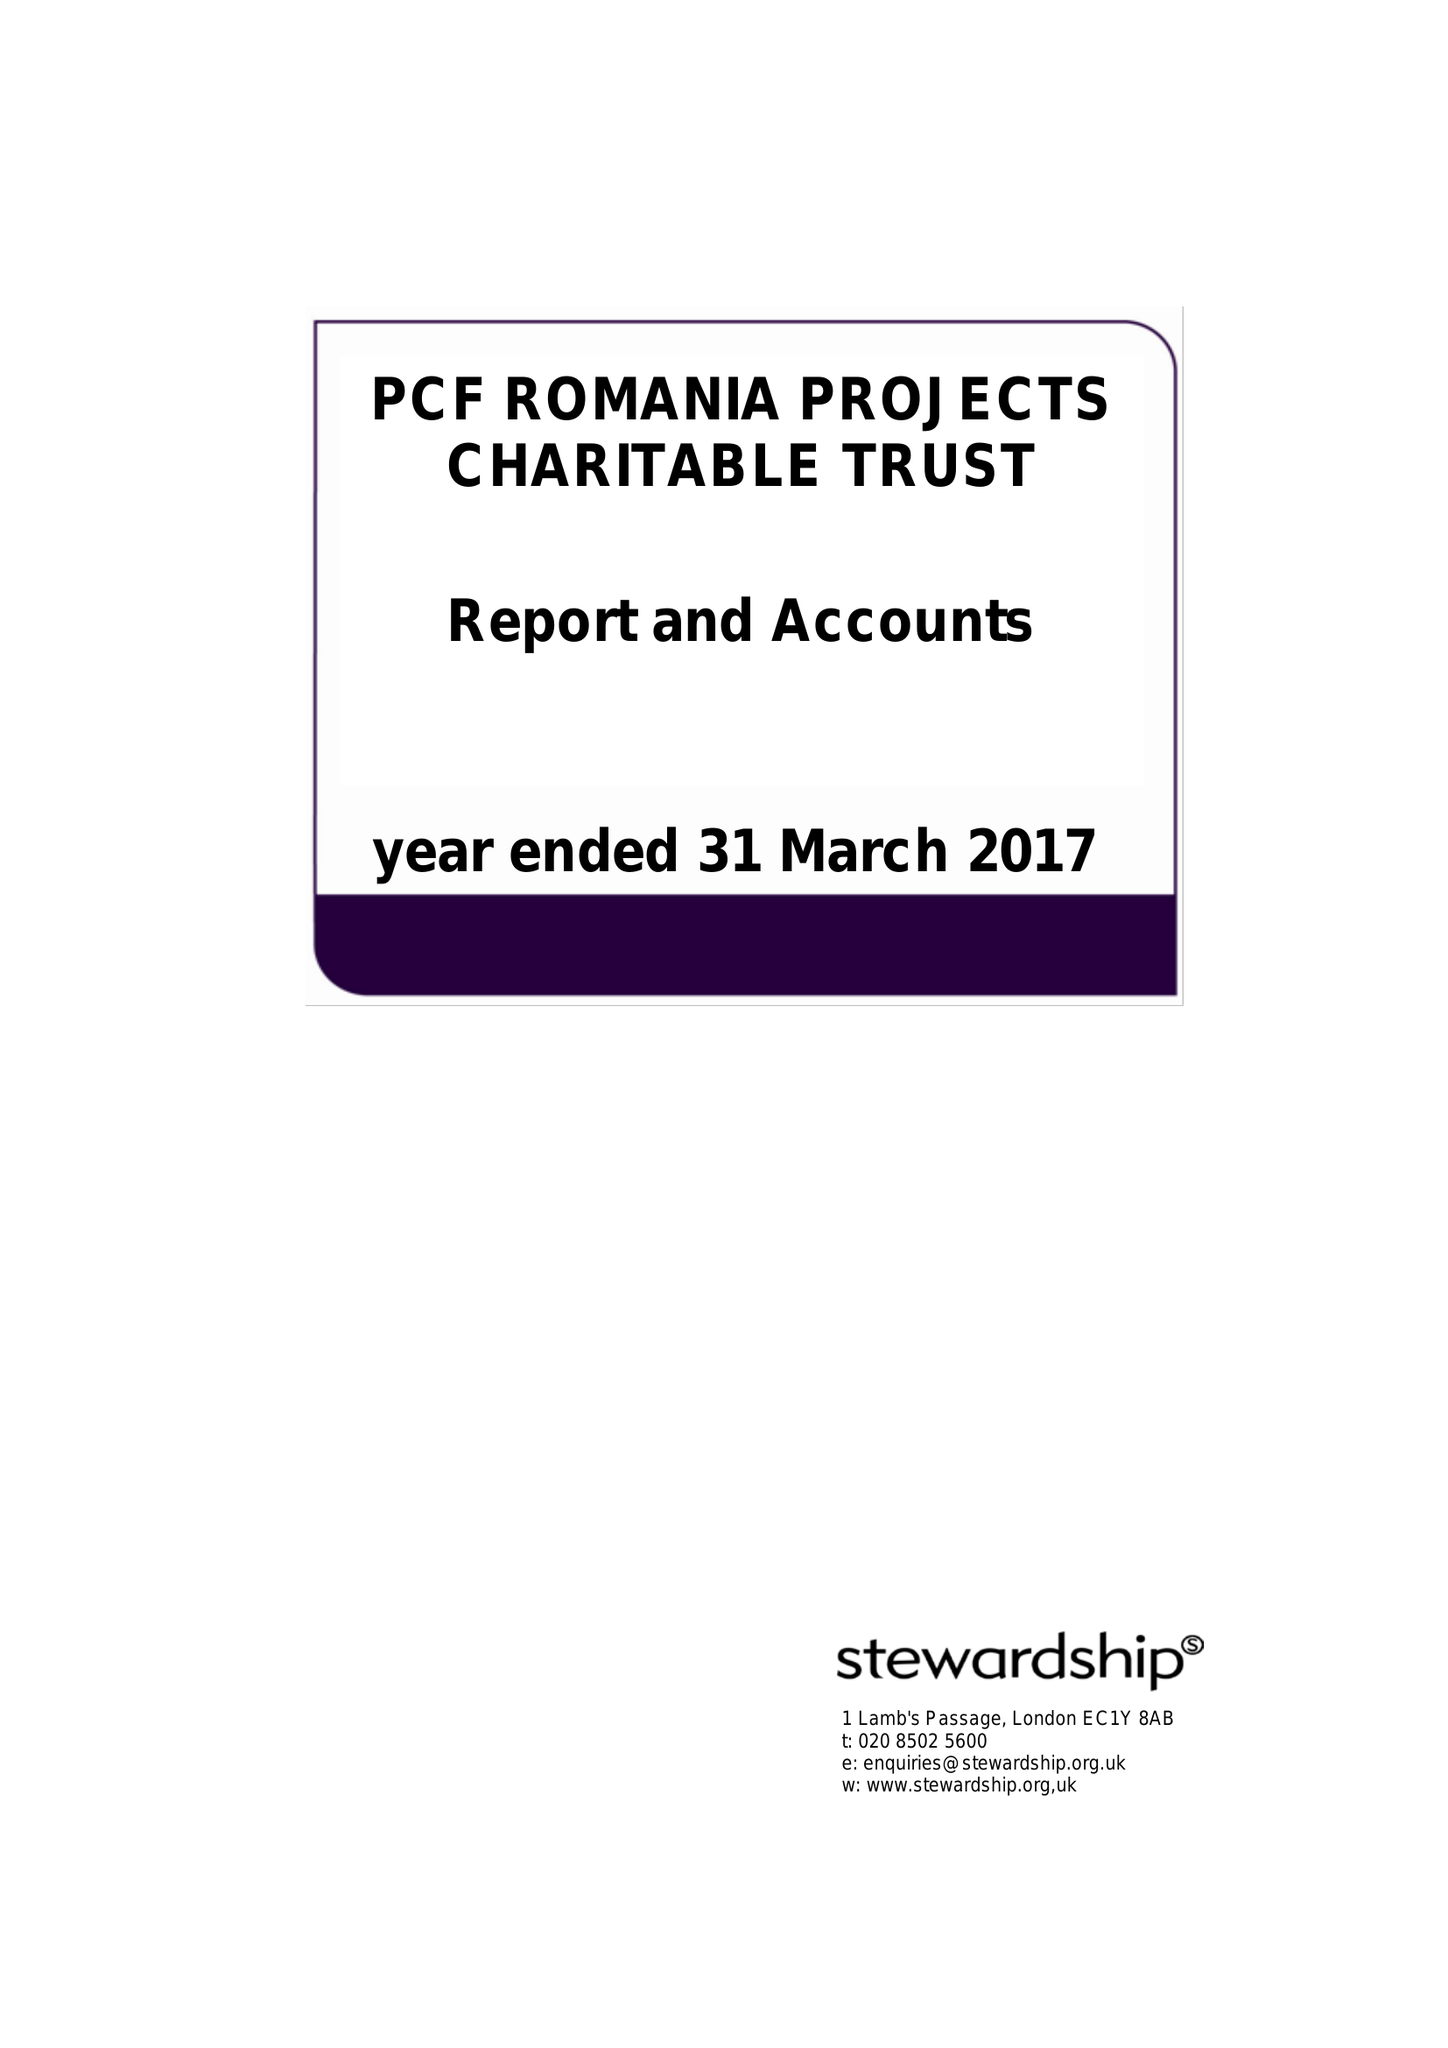What is the value for the income_annually_in_british_pounds?
Answer the question using a single word or phrase. 109619.00 